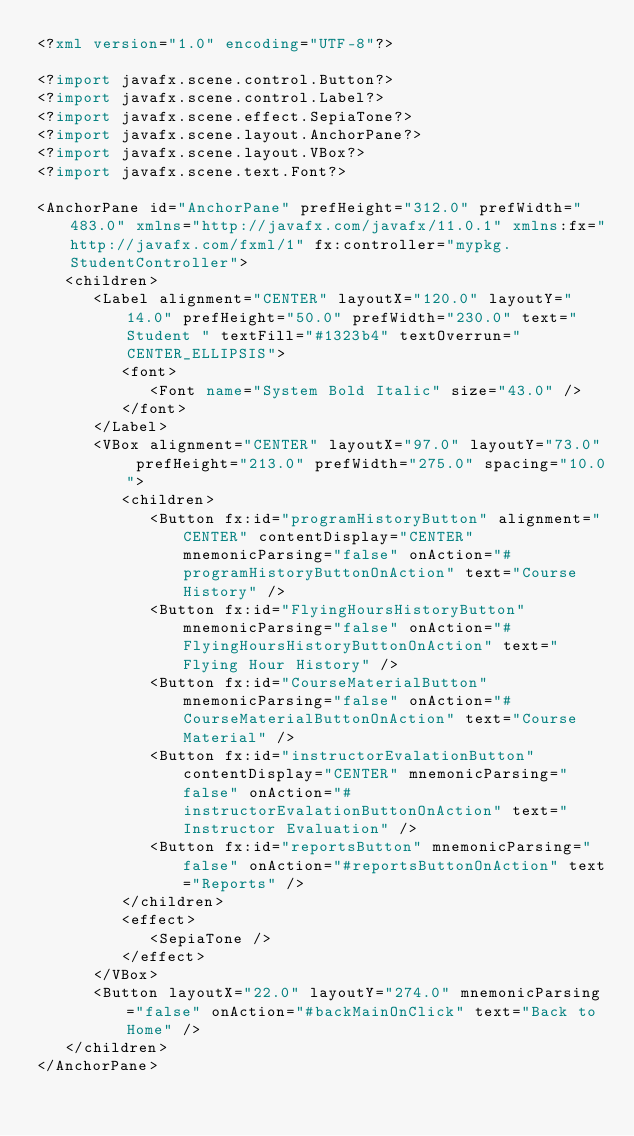Convert code to text. <code><loc_0><loc_0><loc_500><loc_500><_XML_><?xml version="1.0" encoding="UTF-8"?>

<?import javafx.scene.control.Button?>
<?import javafx.scene.control.Label?>
<?import javafx.scene.effect.SepiaTone?>
<?import javafx.scene.layout.AnchorPane?>
<?import javafx.scene.layout.VBox?>
<?import javafx.scene.text.Font?>

<AnchorPane id="AnchorPane" prefHeight="312.0" prefWidth="483.0" xmlns="http://javafx.com/javafx/11.0.1" xmlns:fx="http://javafx.com/fxml/1" fx:controller="mypkg.StudentController">
   <children>
      <Label alignment="CENTER" layoutX="120.0" layoutY="14.0" prefHeight="50.0" prefWidth="230.0" text="Student " textFill="#1323b4" textOverrun="CENTER_ELLIPSIS">
         <font>
            <Font name="System Bold Italic" size="43.0" />
         </font>
      </Label>
      <VBox alignment="CENTER" layoutX="97.0" layoutY="73.0" prefHeight="213.0" prefWidth="275.0" spacing="10.0">
         <children>
            <Button fx:id="programHistoryButton" alignment="CENTER" contentDisplay="CENTER" mnemonicParsing="false" onAction="#programHistoryButtonOnAction" text="Course History" />
            <Button fx:id="FlyingHoursHistoryButton" mnemonicParsing="false" onAction="#FlyingHoursHistoryButtonOnAction" text="Flying Hour History" />
            <Button fx:id="CourseMaterialButton" mnemonicParsing="false" onAction="#CourseMaterialButtonOnAction" text="Course Material" />
            <Button fx:id="instructorEvalationButton" contentDisplay="CENTER" mnemonicParsing="false" onAction="#instructorEvalationButtonOnAction" text="Instructor Evaluation" />
            <Button fx:id="reportsButton" mnemonicParsing="false" onAction="#reportsButtonOnAction" text="Reports" />
         </children>
         <effect>
            <SepiaTone />
         </effect>
      </VBox>
      <Button layoutX="22.0" layoutY="274.0" mnemonicParsing="false" onAction="#backMainOnClick" text="Back to Home" />
   </children>
</AnchorPane>
</code> 